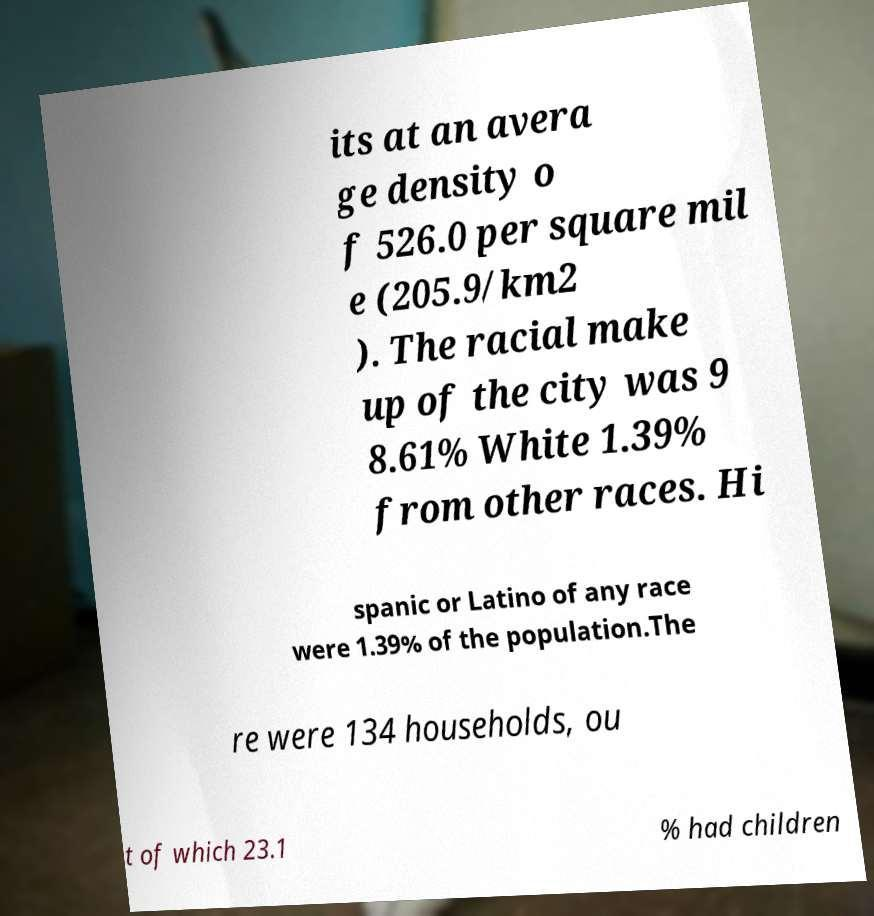Please read and relay the text visible in this image. What does it say? its at an avera ge density o f 526.0 per square mil e (205.9/km2 ). The racial make up of the city was 9 8.61% White 1.39% from other races. Hi spanic or Latino of any race were 1.39% of the population.The re were 134 households, ou t of which 23.1 % had children 